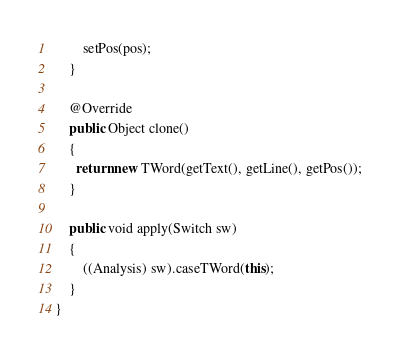Convert code to text. <code><loc_0><loc_0><loc_500><loc_500><_Java_>        setPos(pos);
    }

    @Override
    public Object clone()
    {
      return new TWord(getText(), getLine(), getPos());
    }

    public void apply(Switch sw)
    {
        ((Analysis) sw).caseTWord(this);
    }
}
</code> 